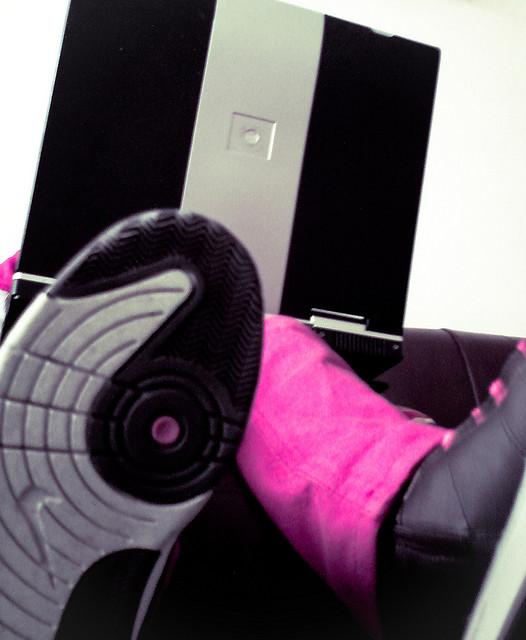What brand shoes are these?
Keep it brief. Nike. What color are the pants?
Give a very brief answer. Pink. Is the person holding a digital device?
Be succinct. Yes. 